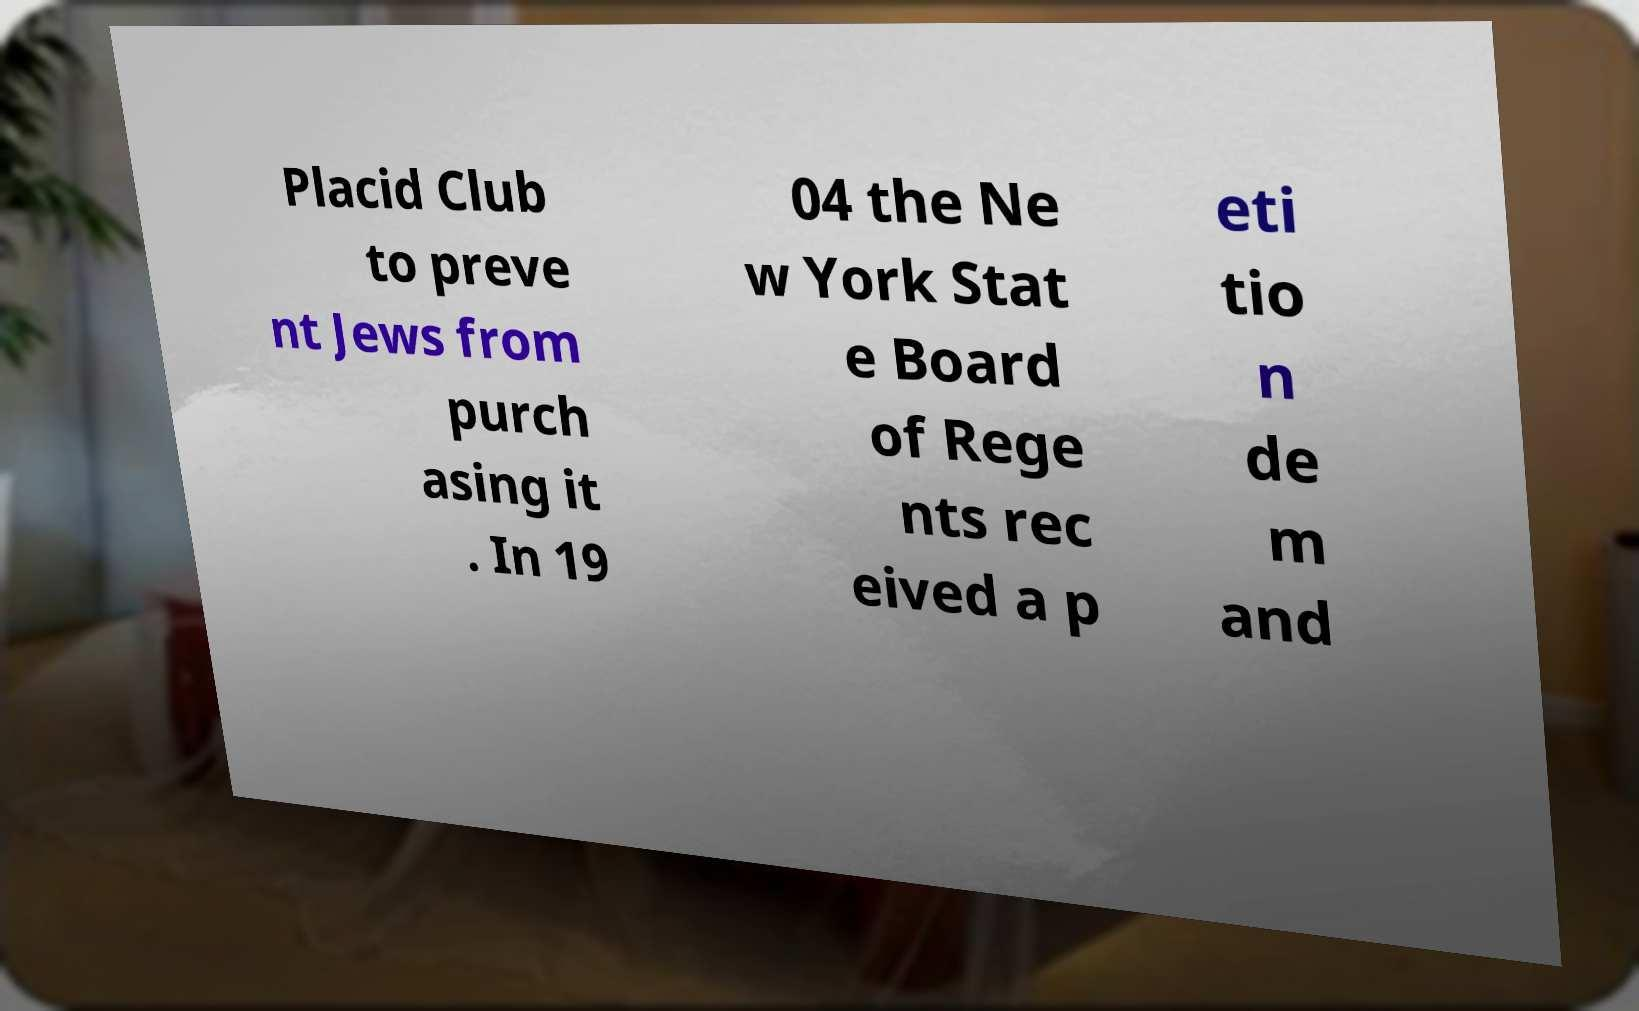What messages or text are displayed in this image? I need them in a readable, typed format. Placid Club to preve nt Jews from purch asing it . In 19 04 the Ne w York Stat e Board of Rege nts rec eived a p eti tio n de m and 